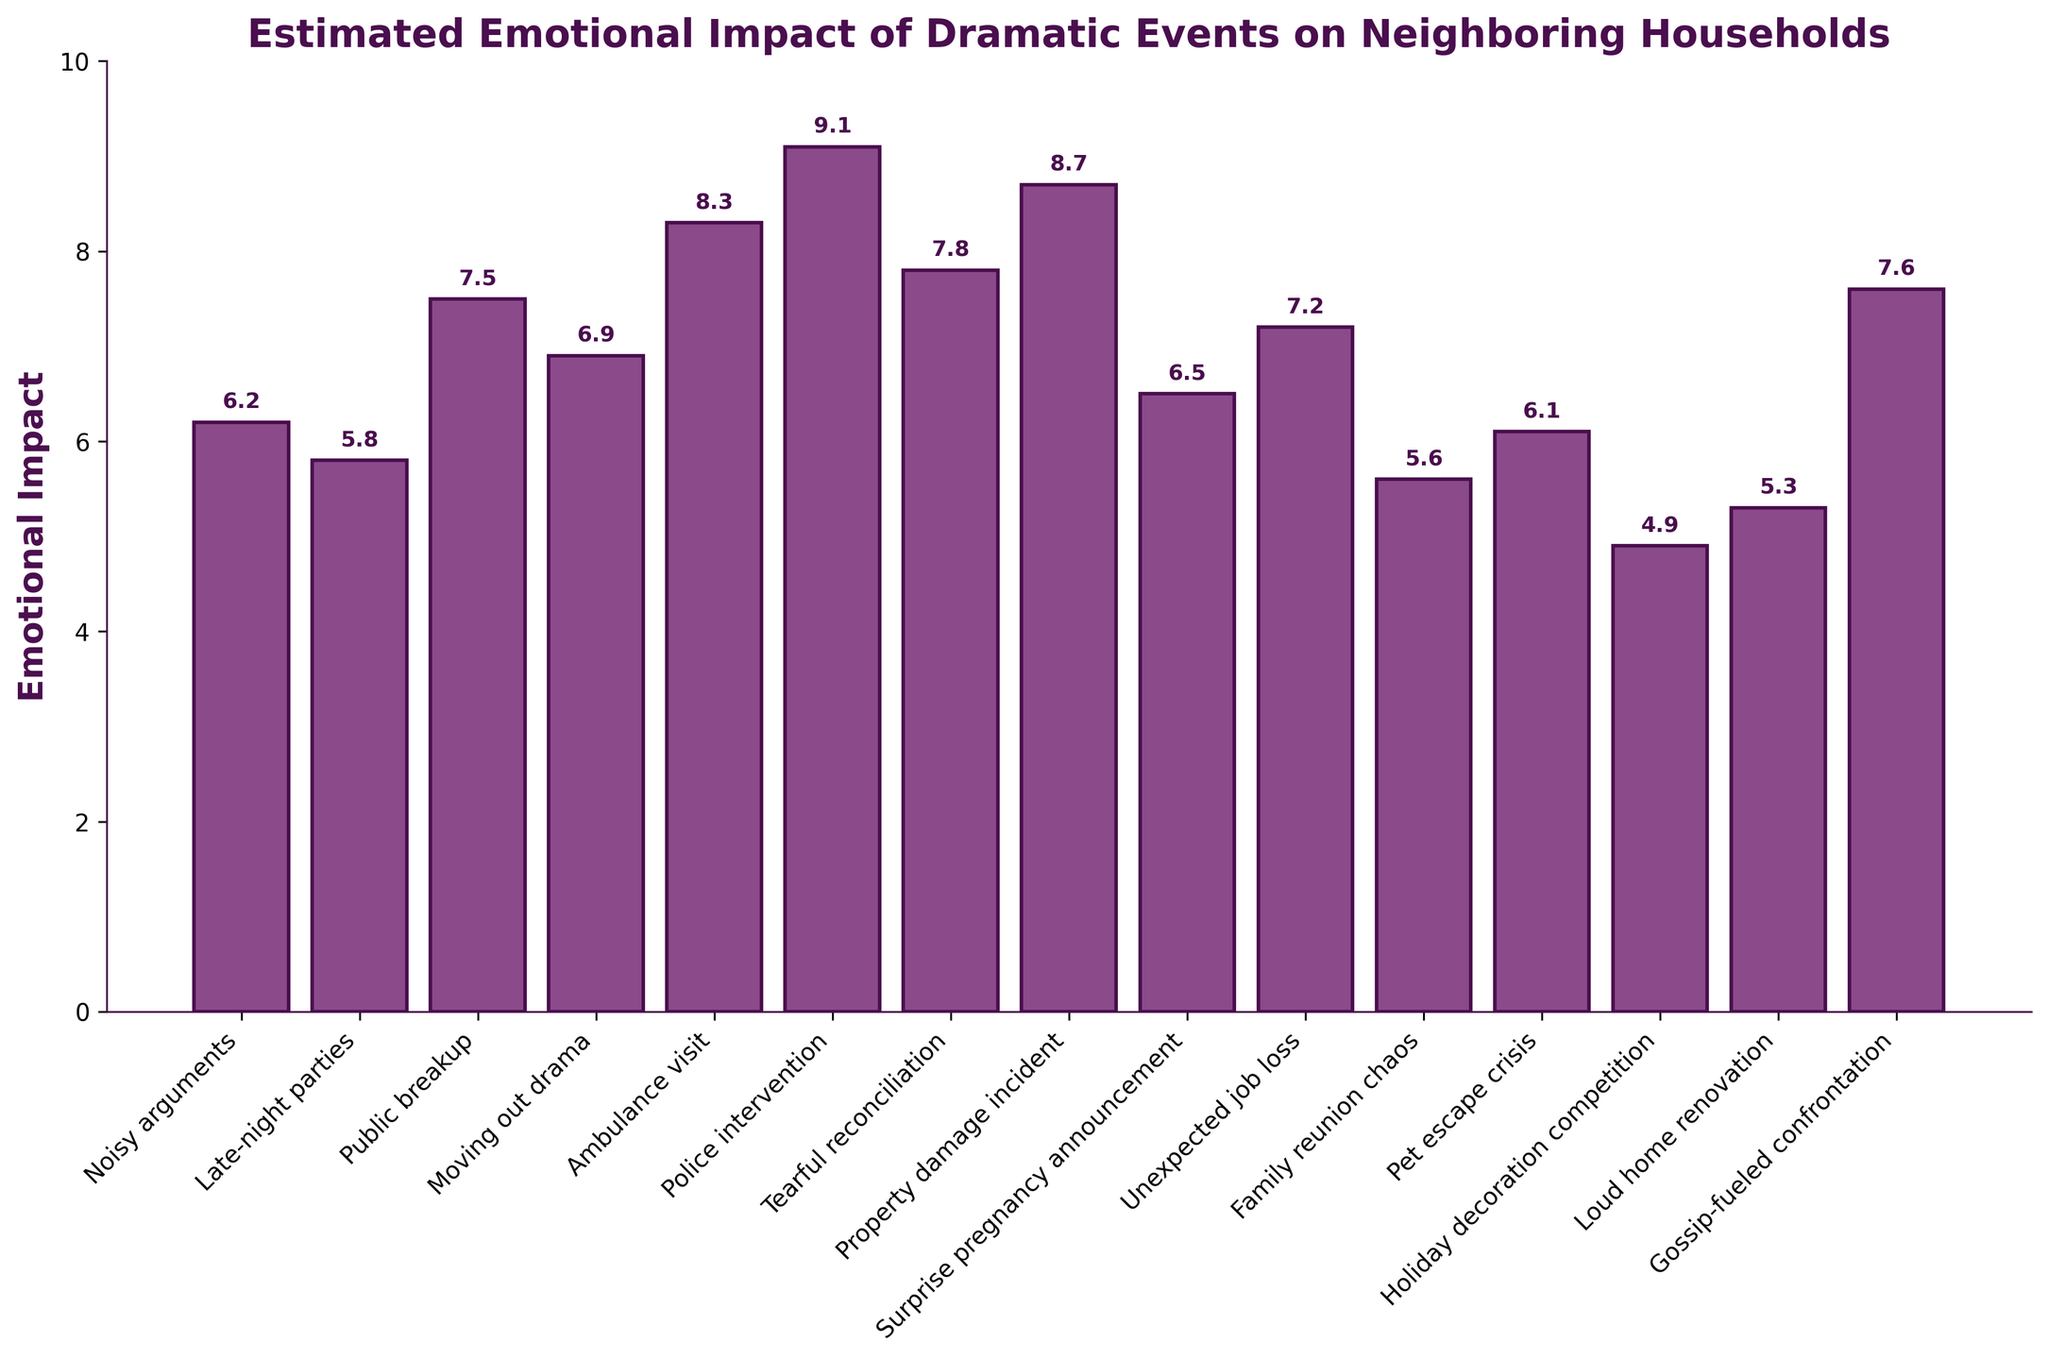What's the event with the highest emotional impact? First, identify the bar with the highest height in the chart to find the event with the highest emotional impact. Here, the "Police intervention" has the highest bar with an emotional impact value of 9.1.
Answer: Police intervention Which two events have almost the same emotional impact? Look for bars that have very similar heights. "Gossip-fueled confrontation" and "Public breakup" have emotional impacts of 7.6 and 7.5, respectively.
Answer: Gossip-fueled confrontation and Public breakup Which event has the lowest emotional impact? Find the bar with the lowest height which corresponds to the event "Holiday decoration competition" with an impact of 4.9.
Answer: Holiday decoration competition What is the average emotional impact of all events? First, sum all the emotional impact values: 6.2 + 5.8 + 7.5 + 6.9 + 8.3 + 9.1 + 7.8 + 8.7 + 6.5 + 7.2 + 5.6 + 6.1 + 4.9 + 5.3 + 7.6 = 103.5. Then, divide by the number of events (15). The average is 103.5 / 15 = 6.9.
Answer: 6.9 How does the emotional impact of 'Ambulance visit' compare to 'Property damage incident'? Identify and compare the heights of the bars. "Ambulance visit" has an emotional impact of 8.3, while "Property damage incident" has an impact of 8.7. So, "Property damage incident" has a higher emotional impact.
Answer: Property damage incident has a higher impact What is the combined emotional impact of 'Noisy arguments' and 'Late-night parties'? Sum the emotional impact values for "Noisy arguments" and "Late-night parties": 6.2 + 5.8 = 12.
Answer: 12 Which event stands out visually due to its particularly high or low impact in relation to the others? Visually, the "Police intervention" stands out as it has the highest bar (9.1) among all events, indicating a particularly high emotional impact.
Answer: Police intervention What is the difference in emotional impact between 'Unexpected job loss' and 'Family reunion chaos'? Subtract the emotional impact of 'Family reunion chaos' from 'Unexpected job loss': 7.2 - 5.6 = 1.6.
Answer: 1.6 Identify the event with a mid-range emotional impact and compare it to 'Tearful reconciliation'. The mid-range emotional impact can be approximated by finding events near the average value. In this case, 'Moving out drama' has an impact of 6.9, close to average, and 'Tearful reconciliation' has an impact of 7.8. Compared to 'Moving out drama', 'Tearful reconciliation' has a higher impact by 0.9.
Answer: Tearful reconciliation has a higher impact by 0.9 Which event has an emotional impact just slightly above 'Pet escape crisis'? Look for an event with an emotional impact slightly higher than 6.1. 'Noisy arguments' has an impact of 6.2, just above 'Pet escape crisis'.
Answer: Noisy arguments 